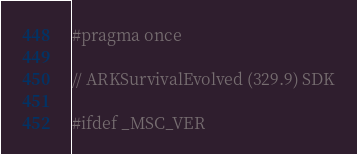Convert code to text. <code><loc_0><loc_0><loc_500><loc_500><_C++_>#pragma once

// ARKSurvivalEvolved (329.9) SDK

#ifdef _MSC_VER</code> 